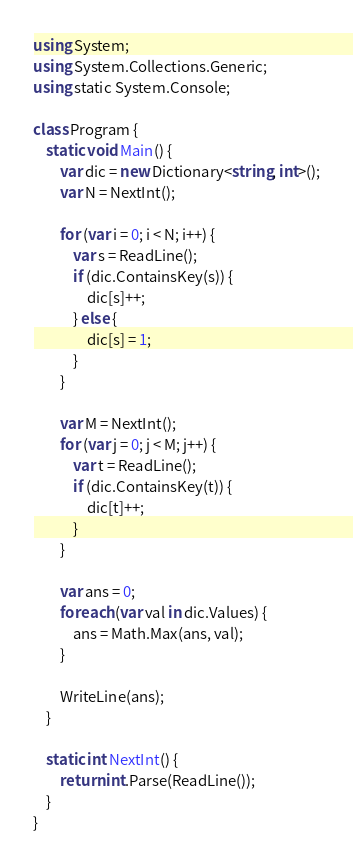<code> <loc_0><loc_0><loc_500><loc_500><_C#_>using System;
using System.Collections.Generic;
using static System.Console;

class Program {
	static void Main() {
		var dic = new Dictionary<string, int>();
		var N = NextInt();

		for (var i = 0; i < N; i++) {
			var s = ReadLine();
			if (dic.ContainsKey(s)) {
				dic[s]++;
			} else {
				dic[s] = 1;
			}
		}

		var M = NextInt();
		for (var j = 0; j < M; j++) {
			var t = ReadLine();
			if (dic.ContainsKey(t)) {
				dic[t]++;
			}
		}

		var ans = 0;
		foreach (var val in dic.Values) {
			ans = Math.Max(ans, val);
		}

		WriteLine(ans);
	}

	static int NextInt() {
		return int.Parse(ReadLine());
	}
}</code> 